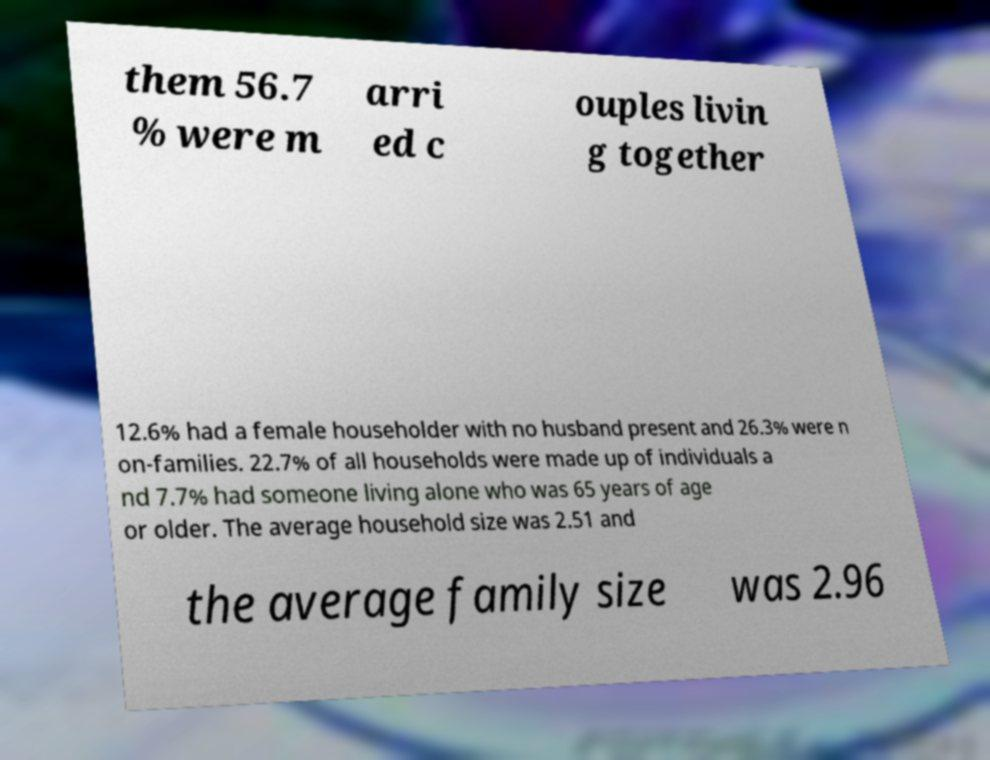There's text embedded in this image that I need extracted. Can you transcribe it verbatim? them 56.7 % were m arri ed c ouples livin g together 12.6% had a female householder with no husband present and 26.3% were n on-families. 22.7% of all households were made up of individuals a nd 7.7% had someone living alone who was 65 years of age or older. The average household size was 2.51 and the average family size was 2.96 